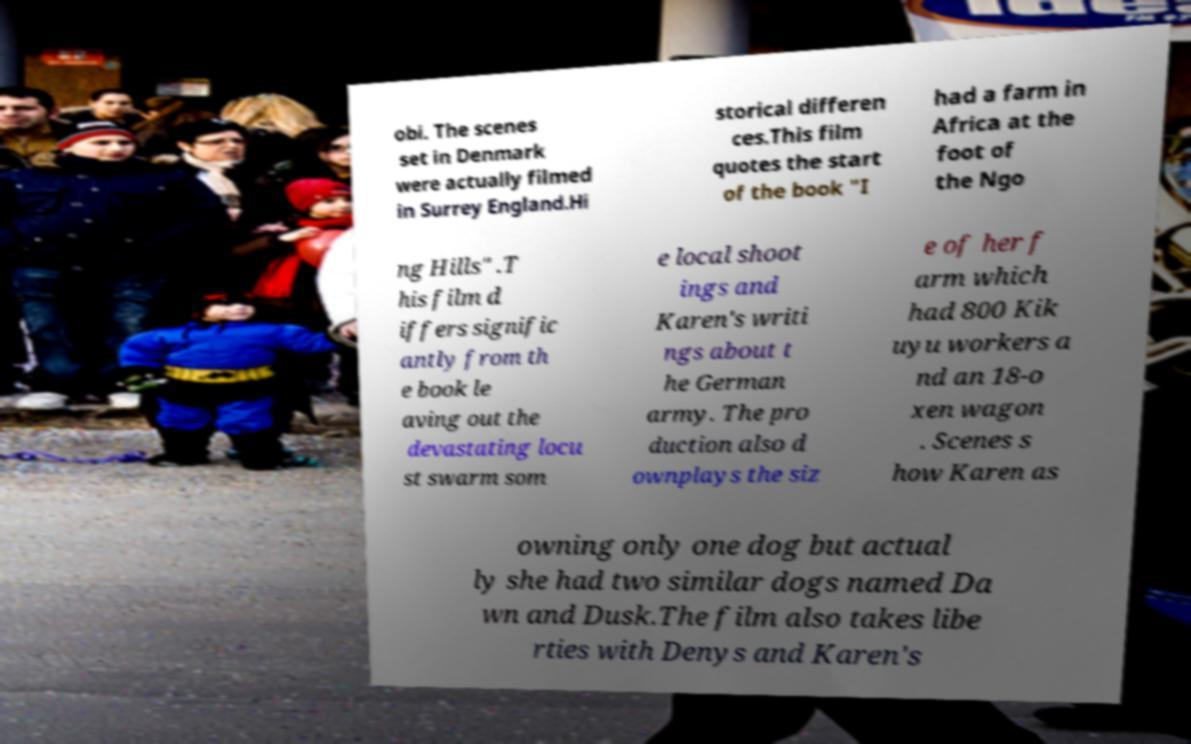For documentation purposes, I need the text within this image transcribed. Could you provide that? obi. The scenes set in Denmark were actually filmed in Surrey England.Hi storical differen ces.This film quotes the start of the book "I had a farm in Africa at the foot of the Ngo ng Hills" .T his film d iffers signific antly from th e book le aving out the devastating locu st swarm som e local shoot ings and Karen's writi ngs about t he German army. The pro duction also d ownplays the siz e of her f arm which had 800 Kik uyu workers a nd an 18-o xen wagon . Scenes s how Karen as owning only one dog but actual ly she had two similar dogs named Da wn and Dusk.The film also takes libe rties with Denys and Karen's 